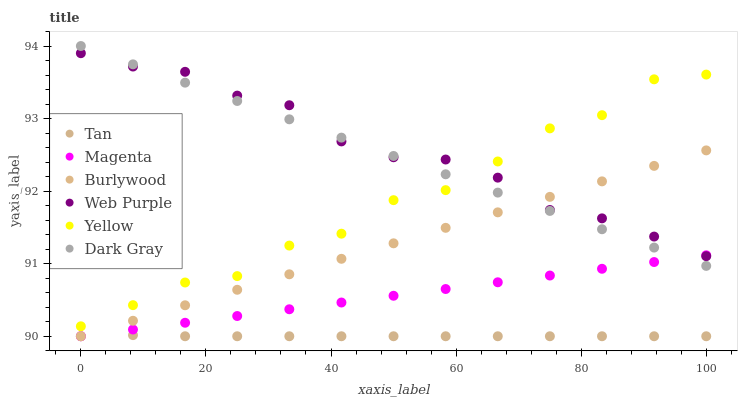Does Tan have the minimum area under the curve?
Answer yes or no. Yes. Does Web Purple have the maximum area under the curve?
Answer yes or no. Yes. Does Yellow have the minimum area under the curve?
Answer yes or no. No. Does Yellow have the maximum area under the curve?
Answer yes or no. No. Is Burlywood the smoothest?
Answer yes or no. Yes. Is Yellow the roughest?
Answer yes or no. Yes. Is Dark Gray the smoothest?
Answer yes or no. No. Is Dark Gray the roughest?
Answer yes or no. No. Does Burlywood have the lowest value?
Answer yes or no. Yes. Does Yellow have the lowest value?
Answer yes or no. No. Does Dark Gray have the highest value?
Answer yes or no. Yes. Does Yellow have the highest value?
Answer yes or no. No. Is Magenta less than Yellow?
Answer yes or no. Yes. Is Yellow greater than Magenta?
Answer yes or no. Yes. Does Web Purple intersect Magenta?
Answer yes or no. Yes. Is Web Purple less than Magenta?
Answer yes or no. No. Is Web Purple greater than Magenta?
Answer yes or no. No. Does Magenta intersect Yellow?
Answer yes or no. No. 